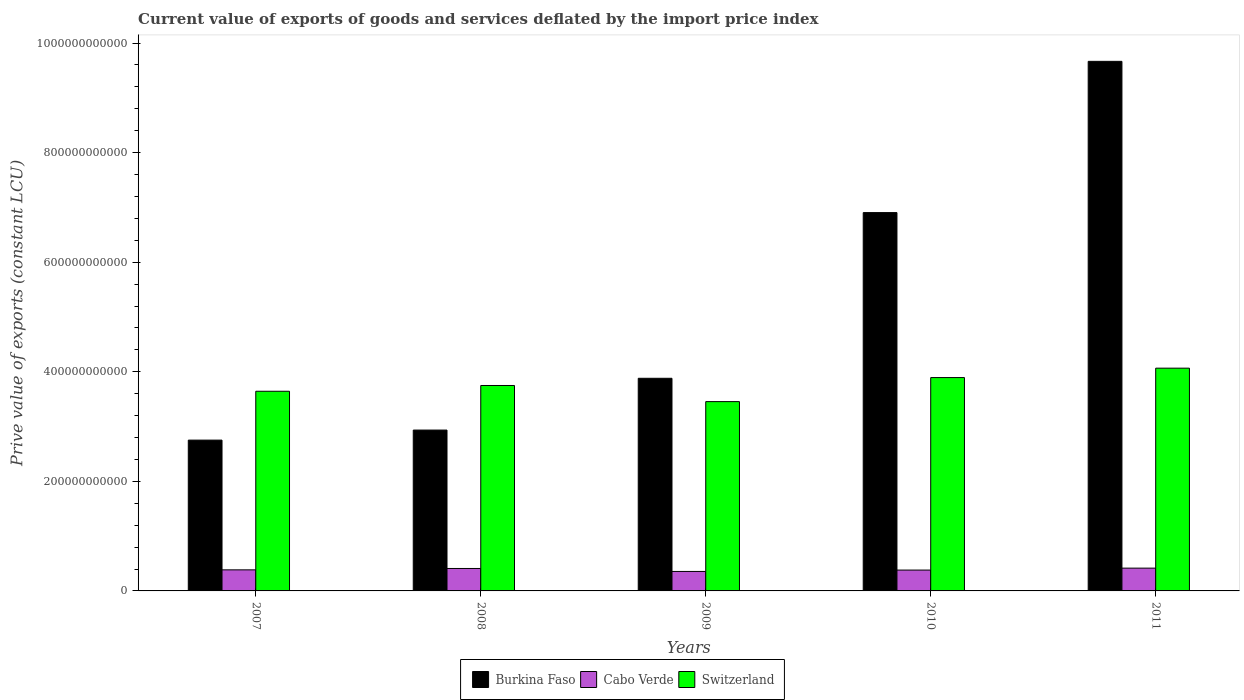How many groups of bars are there?
Provide a succinct answer. 5. Are the number of bars on each tick of the X-axis equal?
Make the answer very short. Yes. How many bars are there on the 3rd tick from the right?
Your answer should be very brief. 3. What is the prive value of exports in Burkina Faso in 2011?
Your answer should be very brief. 9.67e+11. Across all years, what is the maximum prive value of exports in Cabo Verde?
Your answer should be very brief. 4.16e+1. Across all years, what is the minimum prive value of exports in Burkina Faso?
Offer a terse response. 2.75e+11. In which year was the prive value of exports in Cabo Verde minimum?
Your answer should be very brief. 2009. What is the total prive value of exports in Burkina Faso in the graph?
Keep it short and to the point. 2.61e+12. What is the difference between the prive value of exports in Cabo Verde in 2009 and that in 2011?
Offer a very short reply. -6.06e+09. What is the difference between the prive value of exports in Burkina Faso in 2008 and the prive value of exports in Cabo Verde in 2011?
Your answer should be very brief. 2.52e+11. What is the average prive value of exports in Burkina Faso per year?
Keep it short and to the point. 5.23e+11. In the year 2008, what is the difference between the prive value of exports in Cabo Verde and prive value of exports in Burkina Faso?
Keep it short and to the point. -2.53e+11. In how many years, is the prive value of exports in Switzerland greater than 240000000000 LCU?
Offer a terse response. 5. What is the ratio of the prive value of exports in Cabo Verde in 2010 to that in 2011?
Your answer should be compact. 0.91. Is the prive value of exports in Switzerland in 2007 less than that in 2010?
Offer a terse response. Yes. Is the difference between the prive value of exports in Cabo Verde in 2009 and 2011 greater than the difference between the prive value of exports in Burkina Faso in 2009 and 2011?
Keep it short and to the point. Yes. What is the difference between the highest and the second highest prive value of exports in Cabo Verde?
Give a very brief answer. 6.33e+08. What is the difference between the highest and the lowest prive value of exports in Burkina Faso?
Your response must be concise. 6.91e+11. In how many years, is the prive value of exports in Switzerland greater than the average prive value of exports in Switzerland taken over all years?
Your answer should be very brief. 2. What does the 2nd bar from the left in 2010 represents?
Offer a terse response. Cabo Verde. What does the 2nd bar from the right in 2007 represents?
Provide a short and direct response. Cabo Verde. Are all the bars in the graph horizontal?
Make the answer very short. No. How many years are there in the graph?
Your answer should be very brief. 5. What is the difference between two consecutive major ticks on the Y-axis?
Your answer should be very brief. 2.00e+11. Are the values on the major ticks of Y-axis written in scientific E-notation?
Make the answer very short. No. Does the graph contain any zero values?
Give a very brief answer. No. Where does the legend appear in the graph?
Your answer should be compact. Bottom center. How many legend labels are there?
Offer a very short reply. 3. What is the title of the graph?
Ensure brevity in your answer.  Current value of exports of goods and services deflated by the import price index. What is the label or title of the Y-axis?
Provide a short and direct response. Prive value of exports (constant LCU). What is the Prive value of exports (constant LCU) of Burkina Faso in 2007?
Ensure brevity in your answer.  2.75e+11. What is the Prive value of exports (constant LCU) of Cabo Verde in 2007?
Your answer should be very brief. 3.85e+1. What is the Prive value of exports (constant LCU) of Switzerland in 2007?
Offer a very short reply. 3.64e+11. What is the Prive value of exports (constant LCU) in Burkina Faso in 2008?
Your answer should be compact. 2.94e+11. What is the Prive value of exports (constant LCU) in Cabo Verde in 2008?
Make the answer very short. 4.10e+1. What is the Prive value of exports (constant LCU) in Switzerland in 2008?
Your answer should be very brief. 3.75e+11. What is the Prive value of exports (constant LCU) in Burkina Faso in 2009?
Your answer should be compact. 3.88e+11. What is the Prive value of exports (constant LCU) in Cabo Verde in 2009?
Make the answer very short. 3.55e+1. What is the Prive value of exports (constant LCU) of Switzerland in 2009?
Offer a very short reply. 3.46e+11. What is the Prive value of exports (constant LCU) of Burkina Faso in 2010?
Give a very brief answer. 6.91e+11. What is the Prive value of exports (constant LCU) of Cabo Verde in 2010?
Ensure brevity in your answer.  3.81e+1. What is the Prive value of exports (constant LCU) in Switzerland in 2010?
Ensure brevity in your answer.  3.89e+11. What is the Prive value of exports (constant LCU) in Burkina Faso in 2011?
Make the answer very short. 9.67e+11. What is the Prive value of exports (constant LCU) of Cabo Verde in 2011?
Provide a short and direct response. 4.16e+1. What is the Prive value of exports (constant LCU) of Switzerland in 2011?
Offer a terse response. 4.07e+11. Across all years, what is the maximum Prive value of exports (constant LCU) in Burkina Faso?
Offer a terse response. 9.67e+11. Across all years, what is the maximum Prive value of exports (constant LCU) of Cabo Verde?
Your answer should be very brief. 4.16e+1. Across all years, what is the maximum Prive value of exports (constant LCU) of Switzerland?
Ensure brevity in your answer.  4.07e+11. Across all years, what is the minimum Prive value of exports (constant LCU) in Burkina Faso?
Your answer should be very brief. 2.75e+11. Across all years, what is the minimum Prive value of exports (constant LCU) of Cabo Verde?
Make the answer very short. 3.55e+1. Across all years, what is the minimum Prive value of exports (constant LCU) in Switzerland?
Offer a terse response. 3.46e+11. What is the total Prive value of exports (constant LCU) of Burkina Faso in the graph?
Give a very brief answer. 2.61e+12. What is the total Prive value of exports (constant LCU) in Cabo Verde in the graph?
Give a very brief answer. 1.95e+11. What is the total Prive value of exports (constant LCU) of Switzerland in the graph?
Provide a succinct answer. 1.88e+12. What is the difference between the Prive value of exports (constant LCU) of Burkina Faso in 2007 and that in 2008?
Your answer should be very brief. -1.83e+1. What is the difference between the Prive value of exports (constant LCU) in Cabo Verde in 2007 and that in 2008?
Offer a very short reply. -2.50e+09. What is the difference between the Prive value of exports (constant LCU) in Switzerland in 2007 and that in 2008?
Your answer should be compact. -1.05e+1. What is the difference between the Prive value of exports (constant LCU) of Burkina Faso in 2007 and that in 2009?
Your response must be concise. -1.13e+11. What is the difference between the Prive value of exports (constant LCU) in Cabo Verde in 2007 and that in 2009?
Ensure brevity in your answer.  2.93e+09. What is the difference between the Prive value of exports (constant LCU) in Switzerland in 2007 and that in 2009?
Ensure brevity in your answer.  1.89e+1. What is the difference between the Prive value of exports (constant LCU) of Burkina Faso in 2007 and that in 2010?
Your response must be concise. -4.15e+11. What is the difference between the Prive value of exports (constant LCU) of Cabo Verde in 2007 and that in 2010?
Give a very brief answer. 4.10e+08. What is the difference between the Prive value of exports (constant LCU) of Switzerland in 2007 and that in 2010?
Keep it short and to the point. -2.50e+1. What is the difference between the Prive value of exports (constant LCU) of Burkina Faso in 2007 and that in 2011?
Ensure brevity in your answer.  -6.91e+11. What is the difference between the Prive value of exports (constant LCU) of Cabo Verde in 2007 and that in 2011?
Ensure brevity in your answer.  -3.13e+09. What is the difference between the Prive value of exports (constant LCU) of Switzerland in 2007 and that in 2011?
Your answer should be compact. -4.22e+1. What is the difference between the Prive value of exports (constant LCU) in Burkina Faso in 2008 and that in 2009?
Offer a very short reply. -9.45e+1. What is the difference between the Prive value of exports (constant LCU) of Cabo Verde in 2008 and that in 2009?
Ensure brevity in your answer.  5.43e+09. What is the difference between the Prive value of exports (constant LCU) of Switzerland in 2008 and that in 2009?
Offer a very short reply. 2.94e+1. What is the difference between the Prive value of exports (constant LCU) of Burkina Faso in 2008 and that in 2010?
Offer a terse response. -3.97e+11. What is the difference between the Prive value of exports (constant LCU) in Cabo Verde in 2008 and that in 2010?
Your response must be concise. 2.91e+09. What is the difference between the Prive value of exports (constant LCU) of Switzerland in 2008 and that in 2010?
Make the answer very short. -1.45e+1. What is the difference between the Prive value of exports (constant LCU) in Burkina Faso in 2008 and that in 2011?
Make the answer very short. -6.73e+11. What is the difference between the Prive value of exports (constant LCU) in Cabo Verde in 2008 and that in 2011?
Your response must be concise. -6.33e+08. What is the difference between the Prive value of exports (constant LCU) of Switzerland in 2008 and that in 2011?
Offer a terse response. -3.16e+1. What is the difference between the Prive value of exports (constant LCU) of Burkina Faso in 2009 and that in 2010?
Your answer should be very brief. -3.02e+11. What is the difference between the Prive value of exports (constant LCU) of Cabo Verde in 2009 and that in 2010?
Your answer should be very brief. -2.52e+09. What is the difference between the Prive value of exports (constant LCU) of Switzerland in 2009 and that in 2010?
Provide a short and direct response. -4.39e+1. What is the difference between the Prive value of exports (constant LCU) of Burkina Faso in 2009 and that in 2011?
Offer a terse response. -5.79e+11. What is the difference between the Prive value of exports (constant LCU) in Cabo Verde in 2009 and that in 2011?
Give a very brief answer. -6.06e+09. What is the difference between the Prive value of exports (constant LCU) of Switzerland in 2009 and that in 2011?
Provide a short and direct response. -6.11e+1. What is the difference between the Prive value of exports (constant LCU) in Burkina Faso in 2010 and that in 2011?
Make the answer very short. -2.76e+11. What is the difference between the Prive value of exports (constant LCU) of Cabo Verde in 2010 and that in 2011?
Keep it short and to the point. -3.54e+09. What is the difference between the Prive value of exports (constant LCU) of Switzerland in 2010 and that in 2011?
Offer a terse response. -1.72e+1. What is the difference between the Prive value of exports (constant LCU) in Burkina Faso in 2007 and the Prive value of exports (constant LCU) in Cabo Verde in 2008?
Provide a short and direct response. 2.34e+11. What is the difference between the Prive value of exports (constant LCU) of Burkina Faso in 2007 and the Prive value of exports (constant LCU) of Switzerland in 2008?
Provide a succinct answer. -9.97e+1. What is the difference between the Prive value of exports (constant LCU) in Cabo Verde in 2007 and the Prive value of exports (constant LCU) in Switzerland in 2008?
Your answer should be very brief. -3.37e+11. What is the difference between the Prive value of exports (constant LCU) of Burkina Faso in 2007 and the Prive value of exports (constant LCU) of Cabo Verde in 2009?
Give a very brief answer. 2.40e+11. What is the difference between the Prive value of exports (constant LCU) of Burkina Faso in 2007 and the Prive value of exports (constant LCU) of Switzerland in 2009?
Keep it short and to the point. -7.03e+1. What is the difference between the Prive value of exports (constant LCU) in Cabo Verde in 2007 and the Prive value of exports (constant LCU) in Switzerland in 2009?
Provide a short and direct response. -3.07e+11. What is the difference between the Prive value of exports (constant LCU) in Burkina Faso in 2007 and the Prive value of exports (constant LCU) in Cabo Verde in 2010?
Give a very brief answer. 2.37e+11. What is the difference between the Prive value of exports (constant LCU) in Burkina Faso in 2007 and the Prive value of exports (constant LCU) in Switzerland in 2010?
Your response must be concise. -1.14e+11. What is the difference between the Prive value of exports (constant LCU) of Cabo Verde in 2007 and the Prive value of exports (constant LCU) of Switzerland in 2010?
Provide a succinct answer. -3.51e+11. What is the difference between the Prive value of exports (constant LCU) in Burkina Faso in 2007 and the Prive value of exports (constant LCU) in Cabo Verde in 2011?
Keep it short and to the point. 2.34e+11. What is the difference between the Prive value of exports (constant LCU) of Burkina Faso in 2007 and the Prive value of exports (constant LCU) of Switzerland in 2011?
Offer a terse response. -1.31e+11. What is the difference between the Prive value of exports (constant LCU) in Cabo Verde in 2007 and the Prive value of exports (constant LCU) in Switzerland in 2011?
Offer a very short reply. -3.68e+11. What is the difference between the Prive value of exports (constant LCU) of Burkina Faso in 2008 and the Prive value of exports (constant LCU) of Cabo Verde in 2009?
Provide a short and direct response. 2.58e+11. What is the difference between the Prive value of exports (constant LCU) in Burkina Faso in 2008 and the Prive value of exports (constant LCU) in Switzerland in 2009?
Provide a succinct answer. -5.20e+1. What is the difference between the Prive value of exports (constant LCU) in Cabo Verde in 2008 and the Prive value of exports (constant LCU) in Switzerland in 2009?
Offer a terse response. -3.05e+11. What is the difference between the Prive value of exports (constant LCU) of Burkina Faso in 2008 and the Prive value of exports (constant LCU) of Cabo Verde in 2010?
Make the answer very short. 2.56e+11. What is the difference between the Prive value of exports (constant LCU) of Burkina Faso in 2008 and the Prive value of exports (constant LCU) of Switzerland in 2010?
Ensure brevity in your answer.  -9.58e+1. What is the difference between the Prive value of exports (constant LCU) in Cabo Verde in 2008 and the Prive value of exports (constant LCU) in Switzerland in 2010?
Your answer should be compact. -3.48e+11. What is the difference between the Prive value of exports (constant LCU) in Burkina Faso in 2008 and the Prive value of exports (constant LCU) in Cabo Verde in 2011?
Offer a terse response. 2.52e+11. What is the difference between the Prive value of exports (constant LCU) in Burkina Faso in 2008 and the Prive value of exports (constant LCU) in Switzerland in 2011?
Keep it short and to the point. -1.13e+11. What is the difference between the Prive value of exports (constant LCU) in Cabo Verde in 2008 and the Prive value of exports (constant LCU) in Switzerland in 2011?
Your answer should be very brief. -3.66e+11. What is the difference between the Prive value of exports (constant LCU) of Burkina Faso in 2009 and the Prive value of exports (constant LCU) of Cabo Verde in 2010?
Your answer should be compact. 3.50e+11. What is the difference between the Prive value of exports (constant LCU) in Burkina Faso in 2009 and the Prive value of exports (constant LCU) in Switzerland in 2010?
Give a very brief answer. -1.32e+09. What is the difference between the Prive value of exports (constant LCU) of Cabo Verde in 2009 and the Prive value of exports (constant LCU) of Switzerland in 2010?
Keep it short and to the point. -3.54e+11. What is the difference between the Prive value of exports (constant LCU) of Burkina Faso in 2009 and the Prive value of exports (constant LCU) of Cabo Verde in 2011?
Ensure brevity in your answer.  3.47e+11. What is the difference between the Prive value of exports (constant LCU) of Burkina Faso in 2009 and the Prive value of exports (constant LCU) of Switzerland in 2011?
Your answer should be compact. -1.85e+1. What is the difference between the Prive value of exports (constant LCU) in Cabo Verde in 2009 and the Prive value of exports (constant LCU) in Switzerland in 2011?
Your response must be concise. -3.71e+11. What is the difference between the Prive value of exports (constant LCU) in Burkina Faso in 2010 and the Prive value of exports (constant LCU) in Cabo Verde in 2011?
Ensure brevity in your answer.  6.49e+11. What is the difference between the Prive value of exports (constant LCU) in Burkina Faso in 2010 and the Prive value of exports (constant LCU) in Switzerland in 2011?
Provide a short and direct response. 2.84e+11. What is the difference between the Prive value of exports (constant LCU) of Cabo Verde in 2010 and the Prive value of exports (constant LCU) of Switzerland in 2011?
Your answer should be very brief. -3.69e+11. What is the average Prive value of exports (constant LCU) of Burkina Faso per year?
Your answer should be compact. 5.23e+11. What is the average Prive value of exports (constant LCU) in Cabo Verde per year?
Make the answer very short. 3.89e+1. What is the average Prive value of exports (constant LCU) in Switzerland per year?
Your response must be concise. 3.76e+11. In the year 2007, what is the difference between the Prive value of exports (constant LCU) in Burkina Faso and Prive value of exports (constant LCU) in Cabo Verde?
Your answer should be very brief. 2.37e+11. In the year 2007, what is the difference between the Prive value of exports (constant LCU) of Burkina Faso and Prive value of exports (constant LCU) of Switzerland?
Your answer should be compact. -8.92e+1. In the year 2007, what is the difference between the Prive value of exports (constant LCU) in Cabo Verde and Prive value of exports (constant LCU) in Switzerland?
Keep it short and to the point. -3.26e+11. In the year 2008, what is the difference between the Prive value of exports (constant LCU) of Burkina Faso and Prive value of exports (constant LCU) of Cabo Verde?
Keep it short and to the point. 2.53e+11. In the year 2008, what is the difference between the Prive value of exports (constant LCU) in Burkina Faso and Prive value of exports (constant LCU) in Switzerland?
Your response must be concise. -8.14e+1. In the year 2008, what is the difference between the Prive value of exports (constant LCU) of Cabo Verde and Prive value of exports (constant LCU) of Switzerland?
Your response must be concise. -3.34e+11. In the year 2009, what is the difference between the Prive value of exports (constant LCU) in Burkina Faso and Prive value of exports (constant LCU) in Cabo Verde?
Ensure brevity in your answer.  3.53e+11. In the year 2009, what is the difference between the Prive value of exports (constant LCU) of Burkina Faso and Prive value of exports (constant LCU) of Switzerland?
Ensure brevity in your answer.  4.26e+1. In the year 2009, what is the difference between the Prive value of exports (constant LCU) of Cabo Verde and Prive value of exports (constant LCU) of Switzerland?
Ensure brevity in your answer.  -3.10e+11. In the year 2010, what is the difference between the Prive value of exports (constant LCU) in Burkina Faso and Prive value of exports (constant LCU) in Cabo Verde?
Keep it short and to the point. 6.52e+11. In the year 2010, what is the difference between the Prive value of exports (constant LCU) of Burkina Faso and Prive value of exports (constant LCU) of Switzerland?
Make the answer very short. 3.01e+11. In the year 2010, what is the difference between the Prive value of exports (constant LCU) in Cabo Verde and Prive value of exports (constant LCU) in Switzerland?
Make the answer very short. -3.51e+11. In the year 2011, what is the difference between the Prive value of exports (constant LCU) in Burkina Faso and Prive value of exports (constant LCU) in Cabo Verde?
Provide a succinct answer. 9.25e+11. In the year 2011, what is the difference between the Prive value of exports (constant LCU) of Burkina Faso and Prive value of exports (constant LCU) of Switzerland?
Your answer should be very brief. 5.60e+11. In the year 2011, what is the difference between the Prive value of exports (constant LCU) in Cabo Verde and Prive value of exports (constant LCU) in Switzerland?
Provide a succinct answer. -3.65e+11. What is the ratio of the Prive value of exports (constant LCU) in Burkina Faso in 2007 to that in 2008?
Provide a succinct answer. 0.94. What is the ratio of the Prive value of exports (constant LCU) of Cabo Verde in 2007 to that in 2008?
Make the answer very short. 0.94. What is the ratio of the Prive value of exports (constant LCU) in Switzerland in 2007 to that in 2008?
Provide a short and direct response. 0.97. What is the ratio of the Prive value of exports (constant LCU) of Burkina Faso in 2007 to that in 2009?
Your answer should be compact. 0.71. What is the ratio of the Prive value of exports (constant LCU) of Cabo Verde in 2007 to that in 2009?
Your answer should be compact. 1.08. What is the ratio of the Prive value of exports (constant LCU) in Switzerland in 2007 to that in 2009?
Give a very brief answer. 1.05. What is the ratio of the Prive value of exports (constant LCU) of Burkina Faso in 2007 to that in 2010?
Provide a short and direct response. 0.4. What is the ratio of the Prive value of exports (constant LCU) of Cabo Verde in 2007 to that in 2010?
Give a very brief answer. 1.01. What is the ratio of the Prive value of exports (constant LCU) of Switzerland in 2007 to that in 2010?
Your answer should be compact. 0.94. What is the ratio of the Prive value of exports (constant LCU) of Burkina Faso in 2007 to that in 2011?
Offer a terse response. 0.28. What is the ratio of the Prive value of exports (constant LCU) in Cabo Verde in 2007 to that in 2011?
Offer a very short reply. 0.92. What is the ratio of the Prive value of exports (constant LCU) of Switzerland in 2007 to that in 2011?
Provide a succinct answer. 0.9. What is the ratio of the Prive value of exports (constant LCU) of Burkina Faso in 2008 to that in 2009?
Provide a short and direct response. 0.76. What is the ratio of the Prive value of exports (constant LCU) of Cabo Verde in 2008 to that in 2009?
Offer a terse response. 1.15. What is the ratio of the Prive value of exports (constant LCU) of Switzerland in 2008 to that in 2009?
Your answer should be very brief. 1.09. What is the ratio of the Prive value of exports (constant LCU) in Burkina Faso in 2008 to that in 2010?
Make the answer very short. 0.43. What is the ratio of the Prive value of exports (constant LCU) in Cabo Verde in 2008 to that in 2010?
Your answer should be very brief. 1.08. What is the ratio of the Prive value of exports (constant LCU) of Switzerland in 2008 to that in 2010?
Provide a succinct answer. 0.96. What is the ratio of the Prive value of exports (constant LCU) in Burkina Faso in 2008 to that in 2011?
Make the answer very short. 0.3. What is the ratio of the Prive value of exports (constant LCU) of Cabo Verde in 2008 to that in 2011?
Offer a terse response. 0.98. What is the ratio of the Prive value of exports (constant LCU) in Switzerland in 2008 to that in 2011?
Make the answer very short. 0.92. What is the ratio of the Prive value of exports (constant LCU) in Burkina Faso in 2009 to that in 2010?
Ensure brevity in your answer.  0.56. What is the ratio of the Prive value of exports (constant LCU) of Cabo Verde in 2009 to that in 2010?
Make the answer very short. 0.93. What is the ratio of the Prive value of exports (constant LCU) in Switzerland in 2009 to that in 2010?
Make the answer very short. 0.89. What is the ratio of the Prive value of exports (constant LCU) in Burkina Faso in 2009 to that in 2011?
Keep it short and to the point. 0.4. What is the ratio of the Prive value of exports (constant LCU) in Cabo Verde in 2009 to that in 2011?
Keep it short and to the point. 0.85. What is the ratio of the Prive value of exports (constant LCU) of Switzerland in 2009 to that in 2011?
Offer a very short reply. 0.85. What is the ratio of the Prive value of exports (constant LCU) in Burkina Faso in 2010 to that in 2011?
Keep it short and to the point. 0.71. What is the ratio of the Prive value of exports (constant LCU) in Cabo Verde in 2010 to that in 2011?
Offer a terse response. 0.91. What is the ratio of the Prive value of exports (constant LCU) of Switzerland in 2010 to that in 2011?
Offer a terse response. 0.96. What is the difference between the highest and the second highest Prive value of exports (constant LCU) of Burkina Faso?
Make the answer very short. 2.76e+11. What is the difference between the highest and the second highest Prive value of exports (constant LCU) in Cabo Verde?
Ensure brevity in your answer.  6.33e+08. What is the difference between the highest and the second highest Prive value of exports (constant LCU) in Switzerland?
Your answer should be very brief. 1.72e+1. What is the difference between the highest and the lowest Prive value of exports (constant LCU) of Burkina Faso?
Your answer should be very brief. 6.91e+11. What is the difference between the highest and the lowest Prive value of exports (constant LCU) of Cabo Verde?
Ensure brevity in your answer.  6.06e+09. What is the difference between the highest and the lowest Prive value of exports (constant LCU) in Switzerland?
Provide a succinct answer. 6.11e+1. 